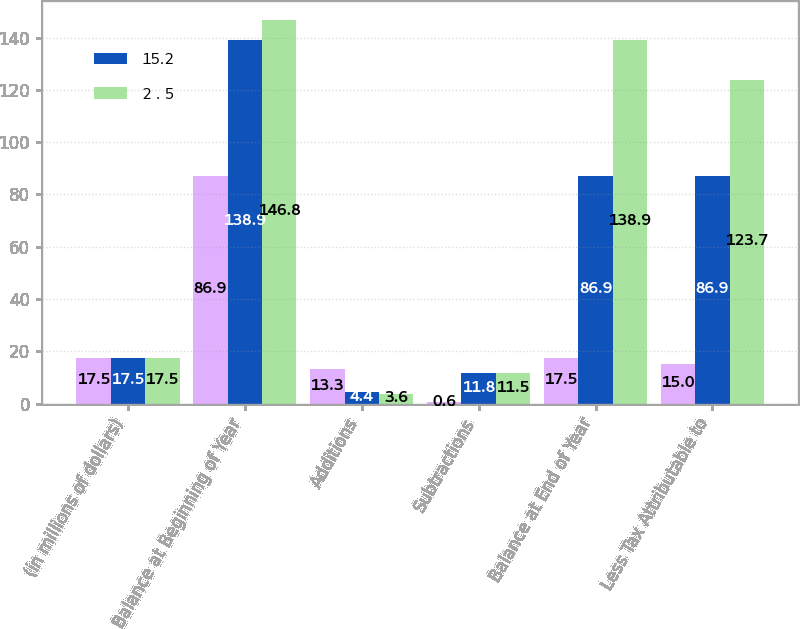<chart> <loc_0><loc_0><loc_500><loc_500><stacked_bar_chart><ecel><fcel>(in millions of dollars)<fcel>Balance at Beginning of Year<fcel>Additions<fcel>Subtractions<fcel>Balance at End of Year<fcel>Less Tax Attributable to<nl><fcel>nan<fcel>17.5<fcel>86.9<fcel>13.3<fcel>0.6<fcel>17.5<fcel>15<nl><fcel>15.2<fcel>17.5<fcel>138.9<fcel>4.4<fcel>11.8<fcel>86.9<fcel>86.9<nl><fcel>2 . 5<fcel>17.5<fcel>146.8<fcel>3.6<fcel>11.5<fcel>138.9<fcel>123.7<nl></chart> 